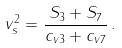<formula> <loc_0><loc_0><loc_500><loc_500>v _ { s } ^ { 2 } = \frac { S _ { 3 } + S _ { 7 } } { c _ { v 3 } + c _ { v 7 } } \, .</formula> 